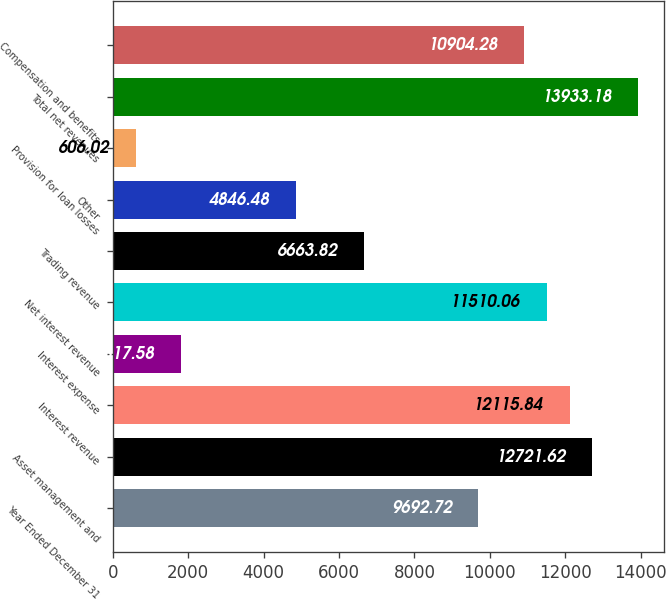<chart> <loc_0><loc_0><loc_500><loc_500><bar_chart><fcel>Year Ended December 31<fcel>Asset management and<fcel>Interest revenue<fcel>Interest expense<fcel>Net interest revenue<fcel>Trading revenue<fcel>Other<fcel>Provision for loan losses<fcel>Total net revenues<fcel>Compensation and benefits<nl><fcel>9692.72<fcel>12721.6<fcel>12115.8<fcel>1817.58<fcel>11510.1<fcel>6663.82<fcel>4846.48<fcel>606.02<fcel>13933.2<fcel>10904.3<nl></chart> 